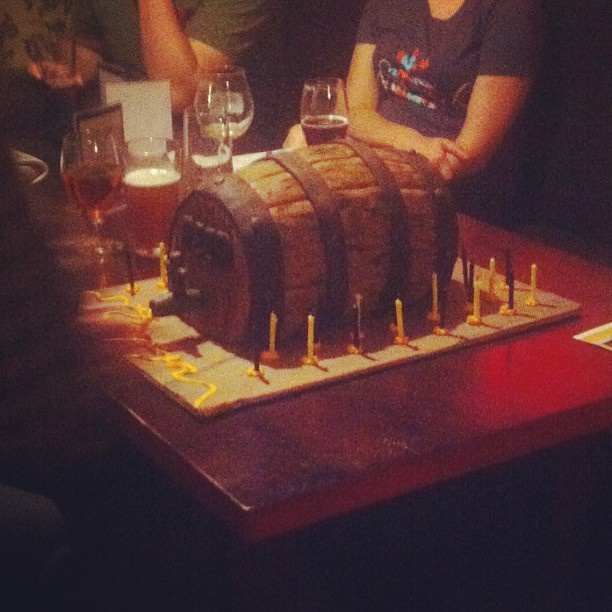Describe the objects in this image and their specific colors. I can see dining table in maroon, brown, and black tones, cake in maroon, brown, and black tones, people in maroon, black, tan, and brown tones, people in maroon, brown, and black tones, and wine glass in maroon, brown, and tan tones in this image. 